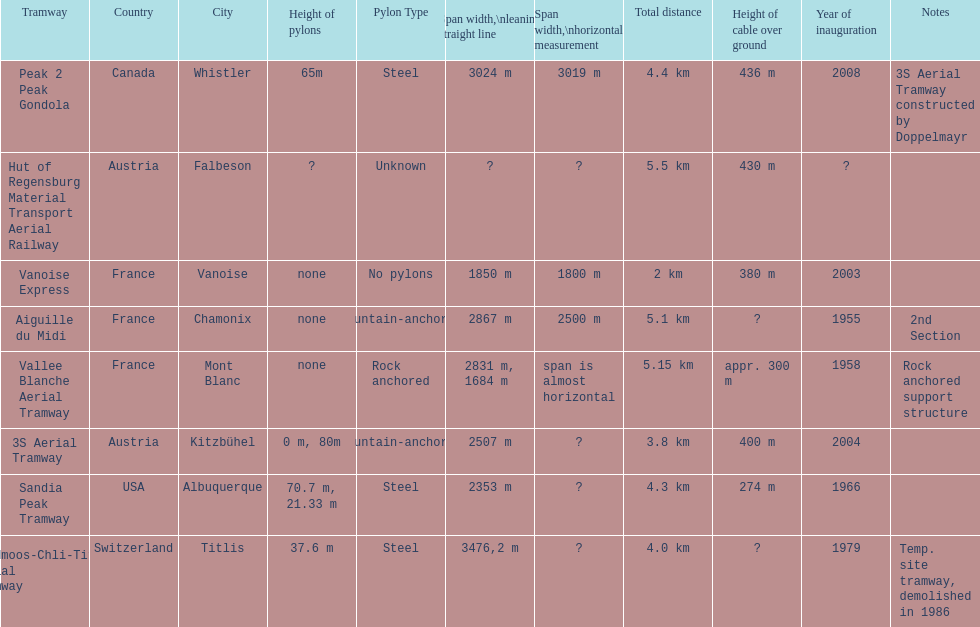How many aerial tramways are located in france? 3. 